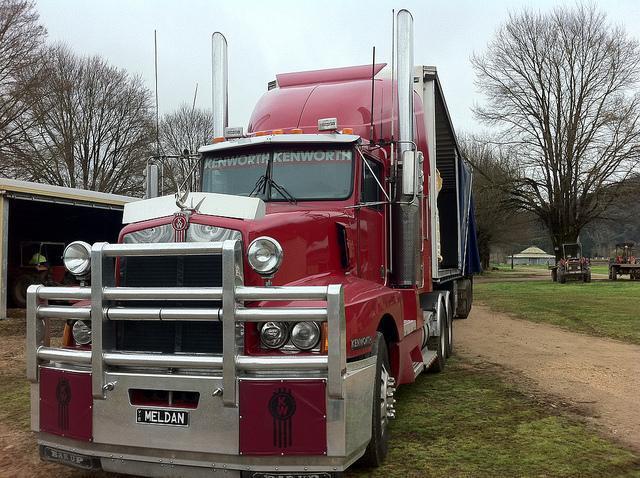How many beds are there?
Give a very brief answer. 0. 